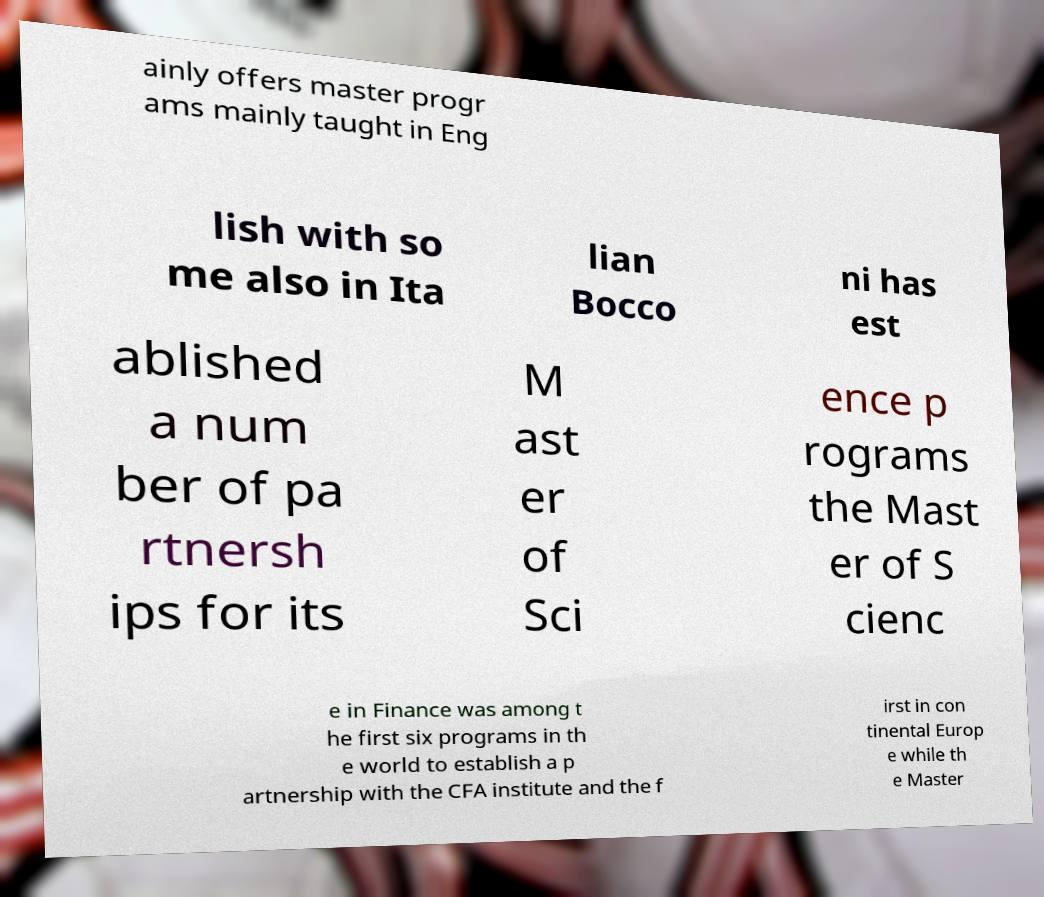I need the written content from this picture converted into text. Can you do that? ainly offers master progr ams mainly taught in Eng lish with so me also in Ita lian Bocco ni has est ablished a num ber of pa rtnersh ips for its M ast er of Sci ence p rograms the Mast er of S cienc e in Finance was among t he first six programs in th e world to establish a p artnership with the CFA institute and the f irst in con tinental Europ e while th e Master 